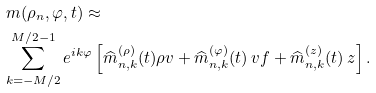<formula> <loc_0><loc_0><loc_500><loc_500>& \ m ( \rho _ { n } , \varphi , t ) \approx \\ & \sum _ { k = - M / 2 } ^ { M / 2 - 1 } e ^ { i k \varphi } \left [ \widehat { m } _ { n , k } ^ { ( \rho ) } ( t ) \rho v + \widehat { m } _ { n , k } ^ { ( \varphi ) } ( t ) \ v f + \widehat { m } _ { n , k } ^ { ( z ) } ( t ) \ z \right ] .</formula> 